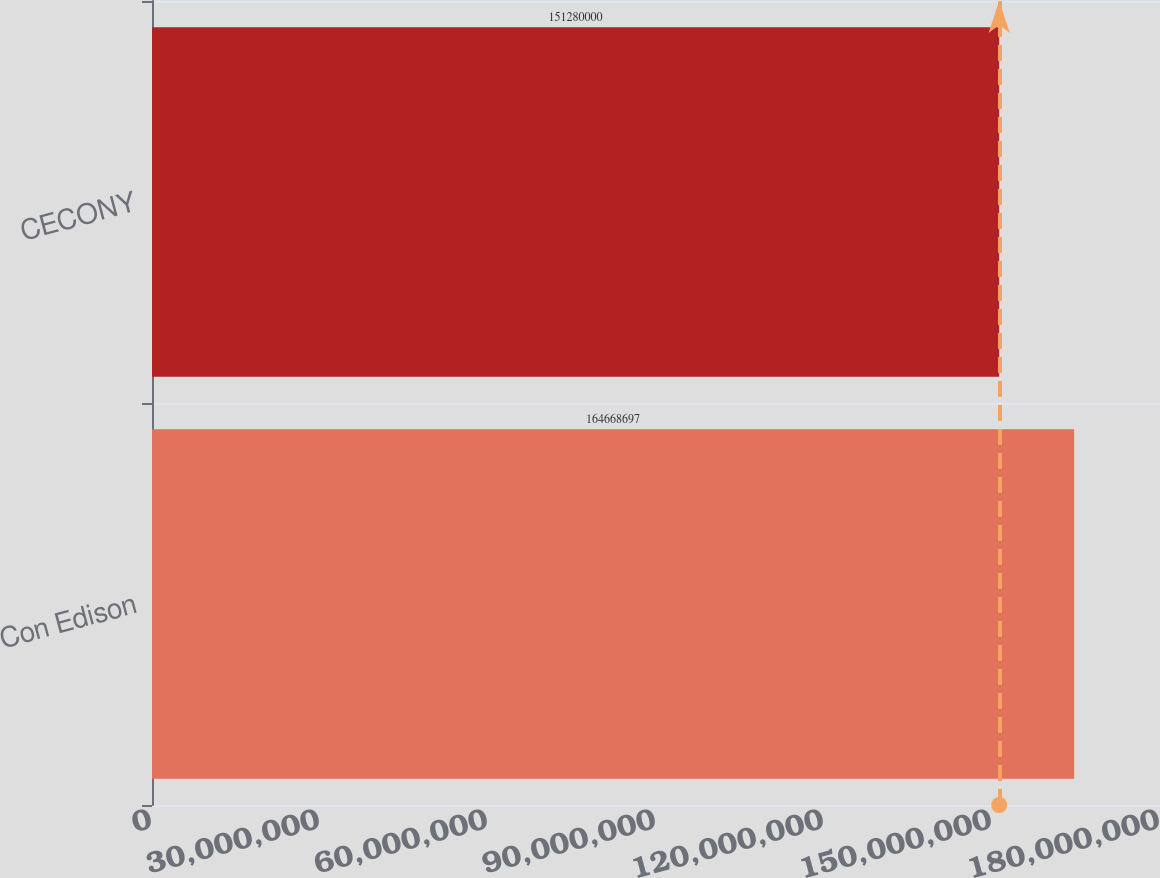<chart> <loc_0><loc_0><loc_500><loc_500><bar_chart><fcel>Con Edison<fcel>CECONY<nl><fcel>1.64669e+08<fcel>1.5128e+08<nl></chart> 